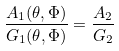<formula> <loc_0><loc_0><loc_500><loc_500>\frac { A _ { 1 } ( \theta , \Phi ) } { G _ { 1 } ( \theta , \Phi ) } = \frac { A _ { 2 } } { G _ { 2 } }</formula> 